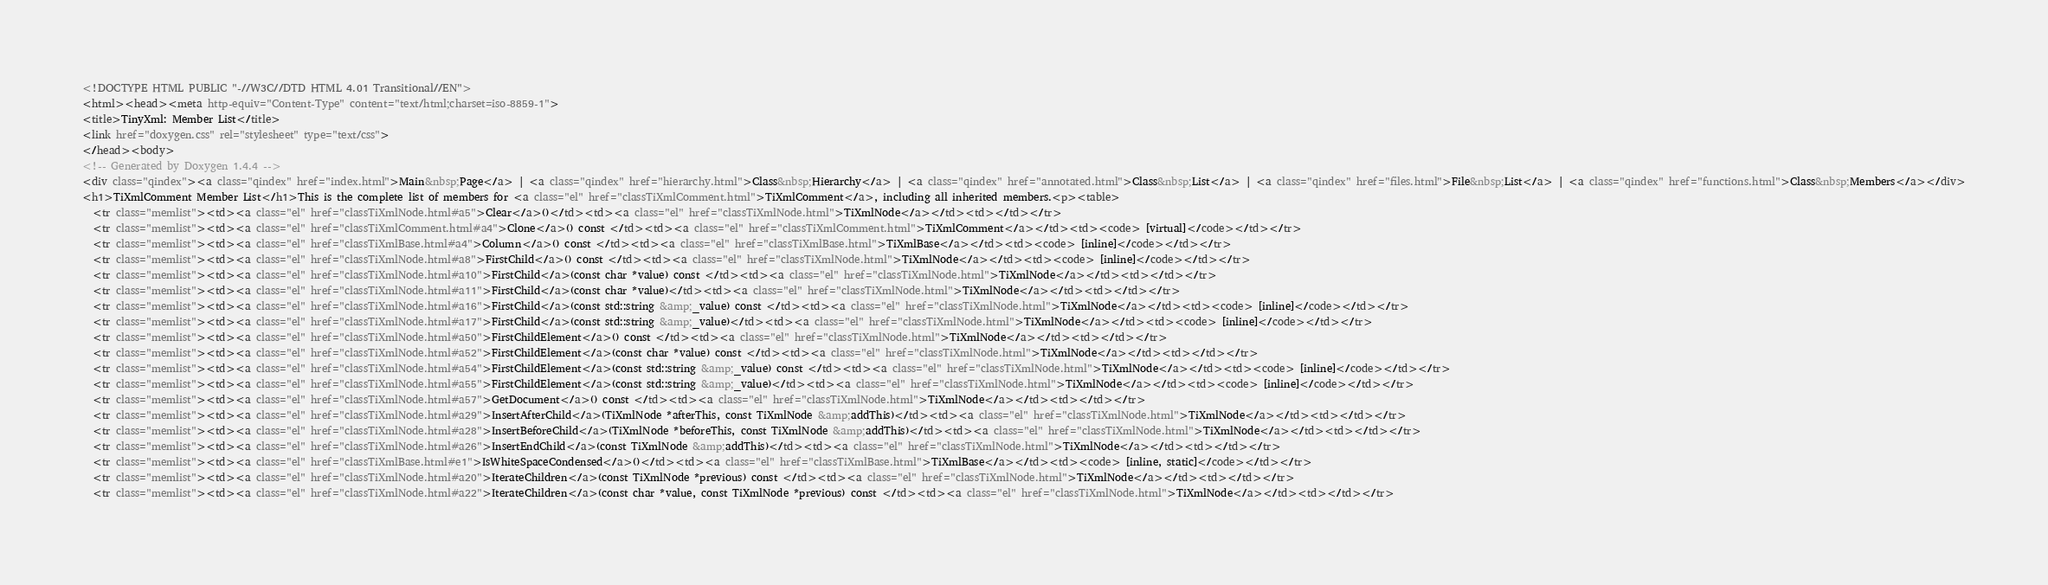<code> <loc_0><loc_0><loc_500><loc_500><_HTML_><!DOCTYPE HTML PUBLIC "-//W3C//DTD HTML 4.01 Transitional//EN">
<html><head><meta http-equiv="Content-Type" content="text/html;charset=iso-8859-1">
<title>TinyXml: Member List</title>
<link href="doxygen.css" rel="stylesheet" type="text/css">
</head><body>
<!-- Generated by Doxygen 1.4.4 -->
<div class="qindex"><a class="qindex" href="index.html">Main&nbsp;Page</a> | <a class="qindex" href="hierarchy.html">Class&nbsp;Hierarchy</a> | <a class="qindex" href="annotated.html">Class&nbsp;List</a> | <a class="qindex" href="files.html">File&nbsp;List</a> | <a class="qindex" href="functions.html">Class&nbsp;Members</a></div>
<h1>TiXmlComment Member List</h1>This is the complete list of members for <a class="el" href="classTiXmlComment.html">TiXmlComment</a>, including all inherited members.<p><table>
  <tr class="memlist"><td><a class="el" href="classTiXmlNode.html#a5">Clear</a>()</td><td><a class="el" href="classTiXmlNode.html">TiXmlNode</a></td><td></td></tr>
  <tr class="memlist"><td><a class="el" href="classTiXmlComment.html#a4">Clone</a>() const </td><td><a class="el" href="classTiXmlComment.html">TiXmlComment</a></td><td><code> [virtual]</code></td></tr>
  <tr class="memlist"><td><a class="el" href="classTiXmlBase.html#a4">Column</a>() const </td><td><a class="el" href="classTiXmlBase.html">TiXmlBase</a></td><td><code> [inline]</code></td></tr>
  <tr class="memlist"><td><a class="el" href="classTiXmlNode.html#a8">FirstChild</a>() const </td><td><a class="el" href="classTiXmlNode.html">TiXmlNode</a></td><td><code> [inline]</code></td></tr>
  <tr class="memlist"><td><a class="el" href="classTiXmlNode.html#a10">FirstChild</a>(const char *value) const </td><td><a class="el" href="classTiXmlNode.html">TiXmlNode</a></td><td></td></tr>
  <tr class="memlist"><td><a class="el" href="classTiXmlNode.html#a11">FirstChild</a>(const char *value)</td><td><a class="el" href="classTiXmlNode.html">TiXmlNode</a></td><td></td></tr>
  <tr class="memlist"><td><a class="el" href="classTiXmlNode.html#a16">FirstChild</a>(const std::string &amp;_value) const </td><td><a class="el" href="classTiXmlNode.html">TiXmlNode</a></td><td><code> [inline]</code></td></tr>
  <tr class="memlist"><td><a class="el" href="classTiXmlNode.html#a17">FirstChild</a>(const std::string &amp;_value)</td><td><a class="el" href="classTiXmlNode.html">TiXmlNode</a></td><td><code> [inline]</code></td></tr>
  <tr class="memlist"><td><a class="el" href="classTiXmlNode.html#a50">FirstChildElement</a>() const </td><td><a class="el" href="classTiXmlNode.html">TiXmlNode</a></td><td></td></tr>
  <tr class="memlist"><td><a class="el" href="classTiXmlNode.html#a52">FirstChildElement</a>(const char *value) const </td><td><a class="el" href="classTiXmlNode.html">TiXmlNode</a></td><td></td></tr>
  <tr class="memlist"><td><a class="el" href="classTiXmlNode.html#a54">FirstChildElement</a>(const std::string &amp;_value) const </td><td><a class="el" href="classTiXmlNode.html">TiXmlNode</a></td><td><code> [inline]</code></td></tr>
  <tr class="memlist"><td><a class="el" href="classTiXmlNode.html#a55">FirstChildElement</a>(const std::string &amp;_value)</td><td><a class="el" href="classTiXmlNode.html">TiXmlNode</a></td><td><code> [inline]</code></td></tr>
  <tr class="memlist"><td><a class="el" href="classTiXmlNode.html#a57">GetDocument</a>() const </td><td><a class="el" href="classTiXmlNode.html">TiXmlNode</a></td><td></td></tr>
  <tr class="memlist"><td><a class="el" href="classTiXmlNode.html#a29">InsertAfterChild</a>(TiXmlNode *afterThis, const TiXmlNode &amp;addThis)</td><td><a class="el" href="classTiXmlNode.html">TiXmlNode</a></td><td></td></tr>
  <tr class="memlist"><td><a class="el" href="classTiXmlNode.html#a28">InsertBeforeChild</a>(TiXmlNode *beforeThis, const TiXmlNode &amp;addThis)</td><td><a class="el" href="classTiXmlNode.html">TiXmlNode</a></td><td></td></tr>
  <tr class="memlist"><td><a class="el" href="classTiXmlNode.html#a26">InsertEndChild</a>(const TiXmlNode &amp;addThis)</td><td><a class="el" href="classTiXmlNode.html">TiXmlNode</a></td><td></td></tr>
  <tr class="memlist"><td><a class="el" href="classTiXmlBase.html#e1">IsWhiteSpaceCondensed</a>()</td><td><a class="el" href="classTiXmlBase.html">TiXmlBase</a></td><td><code> [inline, static]</code></td></tr>
  <tr class="memlist"><td><a class="el" href="classTiXmlNode.html#a20">IterateChildren</a>(const TiXmlNode *previous) const </td><td><a class="el" href="classTiXmlNode.html">TiXmlNode</a></td><td></td></tr>
  <tr class="memlist"><td><a class="el" href="classTiXmlNode.html#a22">IterateChildren</a>(const char *value, const TiXmlNode *previous) const </td><td><a class="el" href="classTiXmlNode.html">TiXmlNode</a></td><td></td></tr></code> 